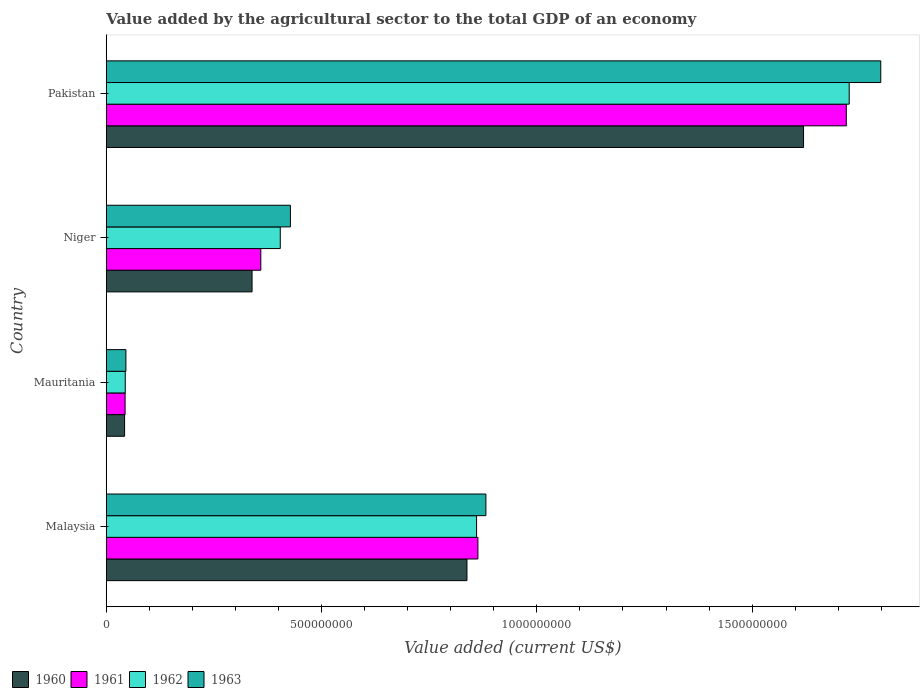Are the number of bars per tick equal to the number of legend labels?
Provide a succinct answer. Yes. What is the label of the 2nd group of bars from the top?
Offer a terse response. Niger. In how many cases, is the number of bars for a given country not equal to the number of legend labels?
Your answer should be very brief. 0. What is the value added by the agricultural sector to the total GDP in 1961 in Pakistan?
Provide a succinct answer. 1.72e+09. Across all countries, what is the maximum value added by the agricultural sector to the total GDP in 1962?
Offer a terse response. 1.73e+09. Across all countries, what is the minimum value added by the agricultural sector to the total GDP in 1960?
Your answer should be very brief. 4.26e+07. In which country was the value added by the agricultural sector to the total GDP in 1962 maximum?
Your answer should be compact. Pakistan. In which country was the value added by the agricultural sector to the total GDP in 1962 minimum?
Give a very brief answer. Mauritania. What is the total value added by the agricultural sector to the total GDP in 1962 in the graph?
Make the answer very short. 3.03e+09. What is the difference between the value added by the agricultural sector to the total GDP in 1962 in Malaysia and that in Niger?
Keep it short and to the point. 4.56e+08. What is the difference between the value added by the agricultural sector to the total GDP in 1962 in Malaysia and the value added by the agricultural sector to the total GDP in 1960 in Pakistan?
Your answer should be compact. -7.59e+08. What is the average value added by the agricultural sector to the total GDP in 1962 per country?
Your answer should be very brief. 7.58e+08. What is the difference between the value added by the agricultural sector to the total GDP in 1961 and value added by the agricultural sector to the total GDP in 1962 in Malaysia?
Keep it short and to the point. 3.09e+06. What is the ratio of the value added by the agricultural sector to the total GDP in 1962 in Malaysia to that in Niger?
Your answer should be very brief. 2.13. Is the difference between the value added by the agricultural sector to the total GDP in 1961 in Mauritania and Niger greater than the difference between the value added by the agricultural sector to the total GDP in 1962 in Mauritania and Niger?
Offer a very short reply. Yes. What is the difference between the highest and the second highest value added by the agricultural sector to the total GDP in 1960?
Your response must be concise. 7.82e+08. What is the difference between the highest and the lowest value added by the agricultural sector to the total GDP in 1960?
Make the answer very short. 1.58e+09. Is the sum of the value added by the agricultural sector to the total GDP in 1960 in Malaysia and Niger greater than the maximum value added by the agricultural sector to the total GDP in 1962 across all countries?
Your response must be concise. No. Is it the case that in every country, the sum of the value added by the agricultural sector to the total GDP in 1960 and value added by the agricultural sector to the total GDP in 1963 is greater than the sum of value added by the agricultural sector to the total GDP in 1961 and value added by the agricultural sector to the total GDP in 1962?
Give a very brief answer. No. What does the 1st bar from the top in Pakistan represents?
Give a very brief answer. 1963. Is it the case that in every country, the sum of the value added by the agricultural sector to the total GDP in 1960 and value added by the agricultural sector to the total GDP in 1963 is greater than the value added by the agricultural sector to the total GDP in 1961?
Make the answer very short. Yes. How many bars are there?
Provide a succinct answer. 16. Are all the bars in the graph horizontal?
Ensure brevity in your answer.  Yes. Where does the legend appear in the graph?
Offer a very short reply. Bottom left. How many legend labels are there?
Offer a very short reply. 4. What is the title of the graph?
Offer a very short reply. Value added by the agricultural sector to the total GDP of an economy. Does "1988" appear as one of the legend labels in the graph?
Your answer should be compact. No. What is the label or title of the X-axis?
Provide a short and direct response. Value added (current US$). What is the label or title of the Y-axis?
Your response must be concise. Country. What is the Value added (current US$) of 1960 in Malaysia?
Offer a terse response. 8.38e+08. What is the Value added (current US$) in 1961 in Malaysia?
Your answer should be compact. 8.63e+08. What is the Value added (current US$) in 1962 in Malaysia?
Make the answer very short. 8.60e+08. What is the Value added (current US$) of 1963 in Malaysia?
Your answer should be compact. 8.82e+08. What is the Value added (current US$) of 1960 in Mauritania?
Ensure brevity in your answer.  4.26e+07. What is the Value added (current US$) in 1961 in Mauritania?
Your response must be concise. 4.37e+07. What is the Value added (current US$) of 1962 in Mauritania?
Your answer should be very brief. 4.41e+07. What is the Value added (current US$) in 1963 in Mauritania?
Offer a terse response. 4.57e+07. What is the Value added (current US$) of 1960 in Niger?
Give a very brief answer. 3.39e+08. What is the Value added (current US$) of 1961 in Niger?
Your answer should be compact. 3.59e+08. What is the Value added (current US$) of 1962 in Niger?
Provide a short and direct response. 4.04e+08. What is the Value added (current US$) in 1963 in Niger?
Give a very brief answer. 4.28e+08. What is the Value added (current US$) of 1960 in Pakistan?
Offer a terse response. 1.62e+09. What is the Value added (current US$) of 1961 in Pakistan?
Offer a terse response. 1.72e+09. What is the Value added (current US$) of 1962 in Pakistan?
Offer a terse response. 1.73e+09. What is the Value added (current US$) of 1963 in Pakistan?
Offer a terse response. 1.80e+09. Across all countries, what is the maximum Value added (current US$) of 1960?
Keep it short and to the point. 1.62e+09. Across all countries, what is the maximum Value added (current US$) of 1961?
Your response must be concise. 1.72e+09. Across all countries, what is the maximum Value added (current US$) in 1962?
Provide a succinct answer. 1.73e+09. Across all countries, what is the maximum Value added (current US$) in 1963?
Provide a succinct answer. 1.80e+09. Across all countries, what is the minimum Value added (current US$) in 1960?
Your answer should be very brief. 4.26e+07. Across all countries, what is the minimum Value added (current US$) of 1961?
Your answer should be very brief. 4.37e+07. Across all countries, what is the minimum Value added (current US$) in 1962?
Provide a short and direct response. 4.41e+07. Across all countries, what is the minimum Value added (current US$) in 1963?
Ensure brevity in your answer.  4.57e+07. What is the total Value added (current US$) of 1960 in the graph?
Keep it short and to the point. 2.84e+09. What is the total Value added (current US$) in 1961 in the graph?
Ensure brevity in your answer.  2.98e+09. What is the total Value added (current US$) in 1962 in the graph?
Provide a short and direct response. 3.03e+09. What is the total Value added (current US$) of 1963 in the graph?
Provide a succinct answer. 3.15e+09. What is the difference between the Value added (current US$) in 1960 in Malaysia and that in Mauritania?
Keep it short and to the point. 7.95e+08. What is the difference between the Value added (current US$) in 1961 in Malaysia and that in Mauritania?
Offer a terse response. 8.19e+08. What is the difference between the Value added (current US$) in 1962 in Malaysia and that in Mauritania?
Keep it short and to the point. 8.16e+08. What is the difference between the Value added (current US$) of 1963 in Malaysia and that in Mauritania?
Offer a very short reply. 8.36e+08. What is the difference between the Value added (current US$) in 1960 in Malaysia and that in Niger?
Your answer should be very brief. 4.99e+08. What is the difference between the Value added (current US$) of 1961 in Malaysia and that in Niger?
Your response must be concise. 5.04e+08. What is the difference between the Value added (current US$) of 1962 in Malaysia and that in Niger?
Ensure brevity in your answer.  4.56e+08. What is the difference between the Value added (current US$) of 1963 in Malaysia and that in Niger?
Give a very brief answer. 4.54e+08. What is the difference between the Value added (current US$) in 1960 in Malaysia and that in Pakistan?
Your answer should be very brief. -7.82e+08. What is the difference between the Value added (current US$) of 1961 in Malaysia and that in Pakistan?
Provide a short and direct response. -8.56e+08. What is the difference between the Value added (current US$) of 1962 in Malaysia and that in Pakistan?
Offer a terse response. -8.65e+08. What is the difference between the Value added (current US$) in 1963 in Malaysia and that in Pakistan?
Ensure brevity in your answer.  -9.17e+08. What is the difference between the Value added (current US$) in 1960 in Mauritania and that in Niger?
Provide a succinct answer. -2.96e+08. What is the difference between the Value added (current US$) in 1961 in Mauritania and that in Niger?
Provide a succinct answer. -3.15e+08. What is the difference between the Value added (current US$) of 1962 in Mauritania and that in Niger?
Your answer should be compact. -3.60e+08. What is the difference between the Value added (current US$) in 1963 in Mauritania and that in Niger?
Provide a short and direct response. -3.82e+08. What is the difference between the Value added (current US$) of 1960 in Mauritania and that in Pakistan?
Provide a short and direct response. -1.58e+09. What is the difference between the Value added (current US$) of 1961 in Mauritania and that in Pakistan?
Keep it short and to the point. -1.67e+09. What is the difference between the Value added (current US$) in 1962 in Mauritania and that in Pakistan?
Your response must be concise. -1.68e+09. What is the difference between the Value added (current US$) of 1963 in Mauritania and that in Pakistan?
Offer a terse response. -1.75e+09. What is the difference between the Value added (current US$) of 1960 in Niger and that in Pakistan?
Make the answer very short. -1.28e+09. What is the difference between the Value added (current US$) in 1961 in Niger and that in Pakistan?
Your response must be concise. -1.36e+09. What is the difference between the Value added (current US$) in 1962 in Niger and that in Pakistan?
Provide a short and direct response. -1.32e+09. What is the difference between the Value added (current US$) in 1963 in Niger and that in Pakistan?
Offer a very short reply. -1.37e+09. What is the difference between the Value added (current US$) in 1960 in Malaysia and the Value added (current US$) in 1961 in Mauritania?
Keep it short and to the point. 7.94e+08. What is the difference between the Value added (current US$) in 1960 in Malaysia and the Value added (current US$) in 1962 in Mauritania?
Your response must be concise. 7.94e+08. What is the difference between the Value added (current US$) in 1960 in Malaysia and the Value added (current US$) in 1963 in Mauritania?
Offer a terse response. 7.92e+08. What is the difference between the Value added (current US$) of 1961 in Malaysia and the Value added (current US$) of 1962 in Mauritania?
Give a very brief answer. 8.19e+08. What is the difference between the Value added (current US$) in 1961 in Malaysia and the Value added (current US$) in 1963 in Mauritania?
Offer a terse response. 8.17e+08. What is the difference between the Value added (current US$) of 1962 in Malaysia and the Value added (current US$) of 1963 in Mauritania?
Give a very brief answer. 8.14e+08. What is the difference between the Value added (current US$) of 1960 in Malaysia and the Value added (current US$) of 1961 in Niger?
Make the answer very short. 4.79e+08. What is the difference between the Value added (current US$) of 1960 in Malaysia and the Value added (current US$) of 1962 in Niger?
Provide a succinct answer. 4.34e+08. What is the difference between the Value added (current US$) in 1960 in Malaysia and the Value added (current US$) in 1963 in Niger?
Your response must be concise. 4.10e+08. What is the difference between the Value added (current US$) of 1961 in Malaysia and the Value added (current US$) of 1962 in Niger?
Provide a short and direct response. 4.59e+08. What is the difference between the Value added (current US$) in 1961 in Malaysia and the Value added (current US$) in 1963 in Niger?
Provide a succinct answer. 4.35e+08. What is the difference between the Value added (current US$) in 1962 in Malaysia and the Value added (current US$) in 1963 in Niger?
Your answer should be very brief. 4.32e+08. What is the difference between the Value added (current US$) in 1960 in Malaysia and the Value added (current US$) in 1961 in Pakistan?
Provide a short and direct response. -8.81e+08. What is the difference between the Value added (current US$) of 1960 in Malaysia and the Value added (current US$) of 1962 in Pakistan?
Keep it short and to the point. -8.88e+08. What is the difference between the Value added (current US$) in 1960 in Malaysia and the Value added (current US$) in 1963 in Pakistan?
Give a very brief answer. -9.61e+08. What is the difference between the Value added (current US$) in 1961 in Malaysia and the Value added (current US$) in 1962 in Pakistan?
Keep it short and to the point. -8.62e+08. What is the difference between the Value added (current US$) of 1961 in Malaysia and the Value added (current US$) of 1963 in Pakistan?
Your answer should be compact. -9.36e+08. What is the difference between the Value added (current US$) in 1962 in Malaysia and the Value added (current US$) in 1963 in Pakistan?
Keep it short and to the point. -9.39e+08. What is the difference between the Value added (current US$) in 1960 in Mauritania and the Value added (current US$) in 1961 in Niger?
Provide a succinct answer. -3.16e+08. What is the difference between the Value added (current US$) of 1960 in Mauritania and the Value added (current US$) of 1962 in Niger?
Your response must be concise. -3.62e+08. What is the difference between the Value added (current US$) in 1960 in Mauritania and the Value added (current US$) in 1963 in Niger?
Provide a succinct answer. -3.85e+08. What is the difference between the Value added (current US$) in 1961 in Mauritania and the Value added (current US$) in 1962 in Niger?
Your response must be concise. -3.60e+08. What is the difference between the Value added (current US$) of 1961 in Mauritania and the Value added (current US$) of 1963 in Niger?
Your answer should be compact. -3.84e+08. What is the difference between the Value added (current US$) of 1962 in Mauritania and the Value added (current US$) of 1963 in Niger?
Your answer should be very brief. -3.84e+08. What is the difference between the Value added (current US$) of 1960 in Mauritania and the Value added (current US$) of 1961 in Pakistan?
Give a very brief answer. -1.68e+09. What is the difference between the Value added (current US$) in 1960 in Mauritania and the Value added (current US$) in 1962 in Pakistan?
Provide a succinct answer. -1.68e+09. What is the difference between the Value added (current US$) of 1960 in Mauritania and the Value added (current US$) of 1963 in Pakistan?
Your response must be concise. -1.76e+09. What is the difference between the Value added (current US$) in 1961 in Mauritania and the Value added (current US$) in 1962 in Pakistan?
Keep it short and to the point. -1.68e+09. What is the difference between the Value added (current US$) of 1961 in Mauritania and the Value added (current US$) of 1963 in Pakistan?
Give a very brief answer. -1.75e+09. What is the difference between the Value added (current US$) of 1962 in Mauritania and the Value added (current US$) of 1963 in Pakistan?
Provide a short and direct response. -1.75e+09. What is the difference between the Value added (current US$) in 1960 in Niger and the Value added (current US$) in 1961 in Pakistan?
Your response must be concise. -1.38e+09. What is the difference between the Value added (current US$) in 1960 in Niger and the Value added (current US$) in 1962 in Pakistan?
Keep it short and to the point. -1.39e+09. What is the difference between the Value added (current US$) of 1960 in Niger and the Value added (current US$) of 1963 in Pakistan?
Provide a succinct answer. -1.46e+09. What is the difference between the Value added (current US$) in 1961 in Niger and the Value added (current US$) in 1962 in Pakistan?
Offer a very short reply. -1.37e+09. What is the difference between the Value added (current US$) of 1961 in Niger and the Value added (current US$) of 1963 in Pakistan?
Keep it short and to the point. -1.44e+09. What is the difference between the Value added (current US$) of 1962 in Niger and the Value added (current US$) of 1963 in Pakistan?
Your answer should be compact. -1.39e+09. What is the average Value added (current US$) of 1960 per country?
Give a very brief answer. 7.10e+08. What is the average Value added (current US$) of 1961 per country?
Ensure brevity in your answer.  7.46e+08. What is the average Value added (current US$) in 1962 per country?
Offer a terse response. 7.58e+08. What is the average Value added (current US$) in 1963 per country?
Ensure brevity in your answer.  7.88e+08. What is the difference between the Value added (current US$) in 1960 and Value added (current US$) in 1961 in Malaysia?
Make the answer very short. -2.54e+07. What is the difference between the Value added (current US$) of 1960 and Value added (current US$) of 1962 in Malaysia?
Offer a terse response. -2.23e+07. What is the difference between the Value added (current US$) of 1960 and Value added (current US$) of 1963 in Malaysia?
Ensure brevity in your answer.  -4.39e+07. What is the difference between the Value added (current US$) in 1961 and Value added (current US$) in 1962 in Malaysia?
Your answer should be very brief. 3.09e+06. What is the difference between the Value added (current US$) of 1961 and Value added (current US$) of 1963 in Malaysia?
Your answer should be very brief. -1.85e+07. What is the difference between the Value added (current US$) in 1962 and Value added (current US$) in 1963 in Malaysia?
Your answer should be very brief. -2.16e+07. What is the difference between the Value added (current US$) of 1960 and Value added (current US$) of 1961 in Mauritania?
Offer a very short reply. -1.15e+06. What is the difference between the Value added (current US$) of 1960 and Value added (current US$) of 1962 in Mauritania?
Make the answer very short. -1.54e+06. What is the difference between the Value added (current US$) in 1960 and Value added (current US$) in 1963 in Mauritania?
Make the answer very short. -3.07e+06. What is the difference between the Value added (current US$) in 1961 and Value added (current US$) in 1962 in Mauritania?
Ensure brevity in your answer.  -3.84e+05. What is the difference between the Value added (current US$) in 1961 and Value added (current US$) in 1963 in Mauritania?
Make the answer very short. -1.92e+06. What is the difference between the Value added (current US$) of 1962 and Value added (current US$) of 1963 in Mauritania?
Your response must be concise. -1.54e+06. What is the difference between the Value added (current US$) in 1960 and Value added (current US$) in 1961 in Niger?
Keep it short and to the point. -2.03e+07. What is the difference between the Value added (current US$) of 1960 and Value added (current US$) of 1962 in Niger?
Your answer should be compact. -6.55e+07. What is the difference between the Value added (current US$) of 1960 and Value added (current US$) of 1963 in Niger?
Provide a short and direct response. -8.91e+07. What is the difference between the Value added (current US$) of 1961 and Value added (current US$) of 1962 in Niger?
Your response must be concise. -4.52e+07. What is the difference between the Value added (current US$) of 1961 and Value added (current US$) of 1963 in Niger?
Your answer should be very brief. -6.88e+07. What is the difference between the Value added (current US$) in 1962 and Value added (current US$) in 1963 in Niger?
Your answer should be compact. -2.36e+07. What is the difference between the Value added (current US$) in 1960 and Value added (current US$) in 1961 in Pakistan?
Your response must be concise. -9.93e+07. What is the difference between the Value added (current US$) in 1960 and Value added (current US$) in 1962 in Pakistan?
Your response must be concise. -1.06e+08. What is the difference between the Value added (current US$) in 1960 and Value added (current US$) in 1963 in Pakistan?
Keep it short and to the point. -1.79e+08. What is the difference between the Value added (current US$) in 1961 and Value added (current US$) in 1962 in Pakistan?
Ensure brevity in your answer.  -6.72e+06. What is the difference between the Value added (current US$) in 1961 and Value added (current US$) in 1963 in Pakistan?
Provide a short and direct response. -8.00e+07. What is the difference between the Value added (current US$) of 1962 and Value added (current US$) of 1963 in Pakistan?
Ensure brevity in your answer.  -7.33e+07. What is the ratio of the Value added (current US$) in 1960 in Malaysia to that in Mauritania?
Keep it short and to the point. 19.67. What is the ratio of the Value added (current US$) of 1961 in Malaysia to that in Mauritania?
Keep it short and to the point. 19.73. What is the ratio of the Value added (current US$) of 1962 in Malaysia to that in Mauritania?
Your response must be concise. 19.49. What is the ratio of the Value added (current US$) of 1963 in Malaysia to that in Mauritania?
Keep it short and to the point. 19.31. What is the ratio of the Value added (current US$) in 1960 in Malaysia to that in Niger?
Keep it short and to the point. 2.47. What is the ratio of the Value added (current US$) of 1961 in Malaysia to that in Niger?
Your response must be concise. 2.4. What is the ratio of the Value added (current US$) of 1962 in Malaysia to that in Niger?
Offer a terse response. 2.13. What is the ratio of the Value added (current US$) in 1963 in Malaysia to that in Niger?
Give a very brief answer. 2.06. What is the ratio of the Value added (current US$) of 1960 in Malaysia to that in Pakistan?
Keep it short and to the point. 0.52. What is the ratio of the Value added (current US$) of 1961 in Malaysia to that in Pakistan?
Your answer should be compact. 0.5. What is the ratio of the Value added (current US$) of 1962 in Malaysia to that in Pakistan?
Keep it short and to the point. 0.5. What is the ratio of the Value added (current US$) of 1963 in Malaysia to that in Pakistan?
Provide a short and direct response. 0.49. What is the ratio of the Value added (current US$) in 1960 in Mauritania to that in Niger?
Offer a very short reply. 0.13. What is the ratio of the Value added (current US$) of 1961 in Mauritania to that in Niger?
Keep it short and to the point. 0.12. What is the ratio of the Value added (current US$) of 1962 in Mauritania to that in Niger?
Keep it short and to the point. 0.11. What is the ratio of the Value added (current US$) of 1963 in Mauritania to that in Niger?
Provide a succinct answer. 0.11. What is the ratio of the Value added (current US$) in 1960 in Mauritania to that in Pakistan?
Make the answer very short. 0.03. What is the ratio of the Value added (current US$) in 1961 in Mauritania to that in Pakistan?
Your answer should be compact. 0.03. What is the ratio of the Value added (current US$) of 1962 in Mauritania to that in Pakistan?
Provide a short and direct response. 0.03. What is the ratio of the Value added (current US$) in 1963 in Mauritania to that in Pakistan?
Provide a short and direct response. 0.03. What is the ratio of the Value added (current US$) in 1960 in Niger to that in Pakistan?
Provide a short and direct response. 0.21. What is the ratio of the Value added (current US$) of 1961 in Niger to that in Pakistan?
Your response must be concise. 0.21. What is the ratio of the Value added (current US$) of 1962 in Niger to that in Pakistan?
Provide a short and direct response. 0.23. What is the ratio of the Value added (current US$) in 1963 in Niger to that in Pakistan?
Offer a terse response. 0.24. What is the difference between the highest and the second highest Value added (current US$) of 1960?
Provide a short and direct response. 7.82e+08. What is the difference between the highest and the second highest Value added (current US$) of 1961?
Give a very brief answer. 8.56e+08. What is the difference between the highest and the second highest Value added (current US$) in 1962?
Your answer should be compact. 8.65e+08. What is the difference between the highest and the second highest Value added (current US$) in 1963?
Give a very brief answer. 9.17e+08. What is the difference between the highest and the lowest Value added (current US$) in 1960?
Make the answer very short. 1.58e+09. What is the difference between the highest and the lowest Value added (current US$) in 1961?
Offer a very short reply. 1.67e+09. What is the difference between the highest and the lowest Value added (current US$) of 1962?
Keep it short and to the point. 1.68e+09. What is the difference between the highest and the lowest Value added (current US$) in 1963?
Your answer should be compact. 1.75e+09. 